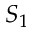<formula> <loc_0><loc_0><loc_500><loc_500>S _ { 1 }</formula> 